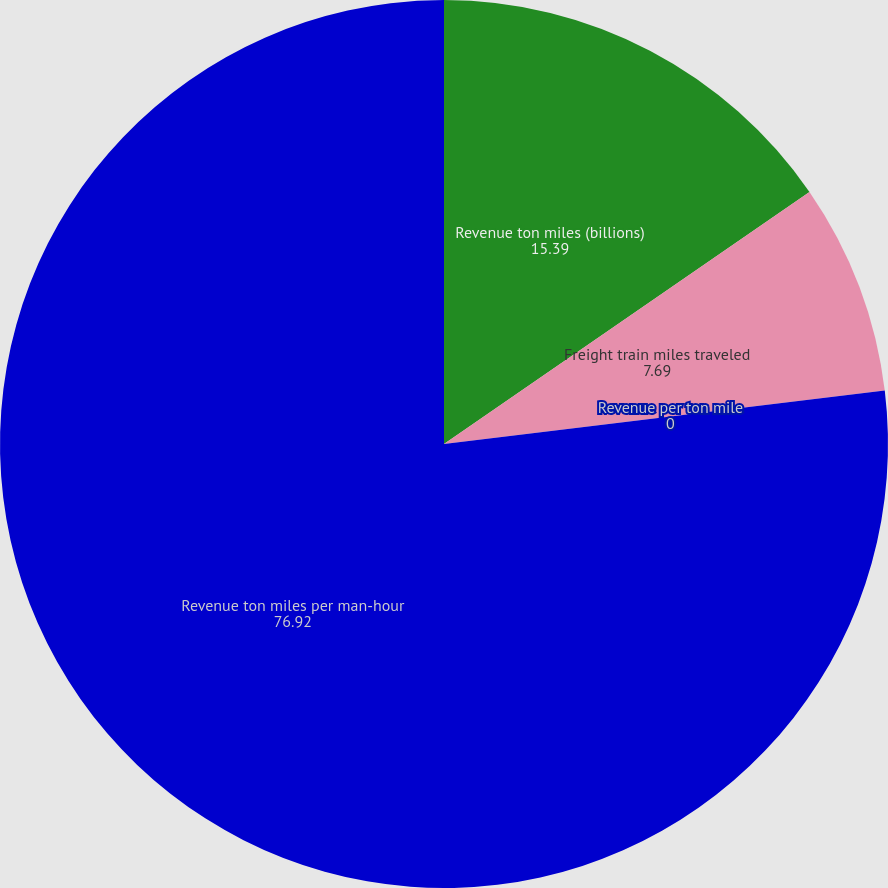Convert chart to OTSL. <chart><loc_0><loc_0><loc_500><loc_500><pie_chart><fcel>Revenue ton miles (billions)<fcel>Freight train miles traveled<fcel>Revenue per ton mile<fcel>Revenue ton miles per man-hour<nl><fcel>15.39%<fcel>7.69%<fcel>0.0%<fcel>76.92%<nl></chart> 